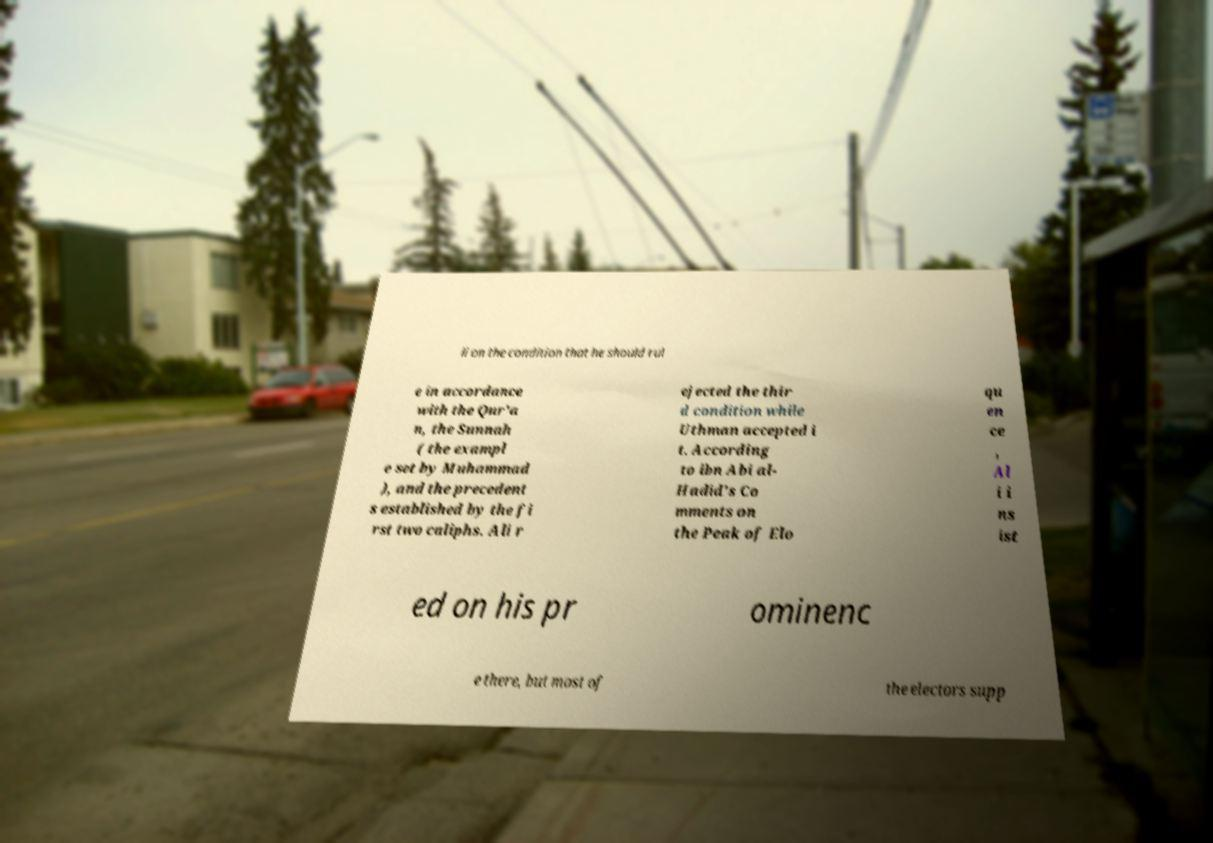I need the written content from this picture converted into text. Can you do that? li on the condition that he should rul e in accordance with the Qur'a n, the Sunnah ( the exampl e set by Muhammad ), and the precedent s established by the fi rst two caliphs. Ali r ejected the thir d condition while Uthman accepted i t. According to ibn Abi al- Hadid's Co mments on the Peak of Elo qu en ce , Al i i ns ist ed on his pr ominenc e there, but most of the electors supp 